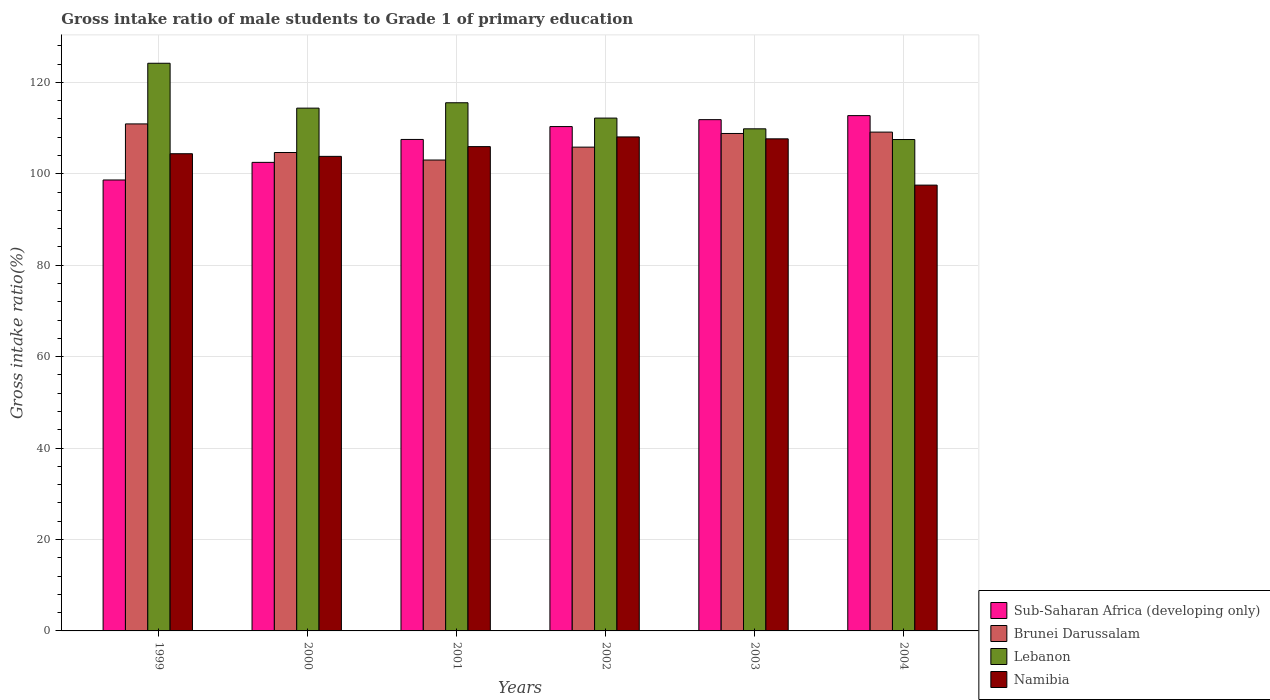How many different coloured bars are there?
Keep it short and to the point. 4. Are the number of bars per tick equal to the number of legend labels?
Provide a short and direct response. Yes. How many bars are there on the 6th tick from the right?
Keep it short and to the point. 4. What is the gross intake ratio in Lebanon in 2004?
Keep it short and to the point. 107.49. Across all years, what is the maximum gross intake ratio in Lebanon?
Give a very brief answer. 124.17. Across all years, what is the minimum gross intake ratio in Brunei Darussalam?
Ensure brevity in your answer.  103. In which year was the gross intake ratio in Sub-Saharan Africa (developing only) minimum?
Provide a succinct answer. 1999. What is the total gross intake ratio in Brunei Darussalam in the graph?
Provide a short and direct response. 642.31. What is the difference between the gross intake ratio in Brunei Darussalam in 2000 and that in 2001?
Offer a terse response. 1.64. What is the difference between the gross intake ratio in Brunei Darussalam in 2003 and the gross intake ratio in Lebanon in 2001?
Make the answer very short. -6.72. What is the average gross intake ratio in Sub-Saharan Africa (developing only) per year?
Ensure brevity in your answer.  107.25. In the year 1999, what is the difference between the gross intake ratio in Sub-Saharan Africa (developing only) and gross intake ratio in Lebanon?
Offer a very short reply. -25.53. In how many years, is the gross intake ratio in Sub-Saharan Africa (developing only) greater than 20 %?
Keep it short and to the point. 6. What is the ratio of the gross intake ratio in Namibia in 2000 to that in 2002?
Give a very brief answer. 0.96. Is the difference between the gross intake ratio in Sub-Saharan Africa (developing only) in 2000 and 2002 greater than the difference between the gross intake ratio in Lebanon in 2000 and 2002?
Ensure brevity in your answer.  No. What is the difference between the highest and the second highest gross intake ratio in Brunei Darussalam?
Offer a terse response. 1.79. What is the difference between the highest and the lowest gross intake ratio in Sub-Saharan Africa (developing only)?
Provide a succinct answer. 14.08. In how many years, is the gross intake ratio in Namibia greater than the average gross intake ratio in Namibia taken over all years?
Provide a succinct answer. 3. Is it the case that in every year, the sum of the gross intake ratio in Sub-Saharan Africa (developing only) and gross intake ratio in Brunei Darussalam is greater than the sum of gross intake ratio in Namibia and gross intake ratio in Lebanon?
Provide a short and direct response. No. What does the 4th bar from the left in 1999 represents?
Give a very brief answer. Namibia. What does the 3rd bar from the right in 2000 represents?
Your answer should be compact. Brunei Darussalam. How many bars are there?
Ensure brevity in your answer.  24. How many years are there in the graph?
Your answer should be very brief. 6. Are the values on the major ticks of Y-axis written in scientific E-notation?
Provide a succinct answer. No. Does the graph contain any zero values?
Give a very brief answer. No. Does the graph contain grids?
Your answer should be compact. Yes. Where does the legend appear in the graph?
Provide a short and direct response. Bottom right. How many legend labels are there?
Make the answer very short. 4. How are the legend labels stacked?
Provide a succinct answer. Vertical. What is the title of the graph?
Your answer should be compact. Gross intake ratio of male students to Grade 1 of primary education. What is the label or title of the X-axis?
Your response must be concise. Years. What is the label or title of the Y-axis?
Offer a very short reply. Gross intake ratio(%). What is the Gross intake ratio(%) in Sub-Saharan Africa (developing only) in 1999?
Provide a short and direct response. 98.64. What is the Gross intake ratio(%) in Brunei Darussalam in 1999?
Provide a short and direct response. 110.91. What is the Gross intake ratio(%) in Lebanon in 1999?
Make the answer very short. 124.17. What is the Gross intake ratio(%) in Namibia in 1999?
Make the answer very short. 104.38. What is the Gross intake ratio(%) in Sub-Saharan Africa (developing only) in 2000?
Keep it short and to the point. 102.49. What is the Gross intake ratio(%) of Brunei Darussalam in 2000?
Provide a succinct answer. 104.65. What is the Gross intake ratio(%) of Lebanon in 2000?
Keep it short and to the point. 114.35. What is the Gross intake ratio(%) of Namibia in 2000?
Provide a short and direct response. 103.81. What is the Gross intake ratio(%) in Sub-Saharan Africa (developing only) in 2001?
Keep it short and to the point. 107.51. What is the Gross intake ratio(%) in Brunei Darussalam in 2001?
Offer a very short reply. 103. What is the Gross intake ratio(%) in Lebanon in 2001?
Your answer should be very brief. 115.53. What is the Gross intake ratio(%) of Namibia in 2001?
Offer a terse response. 105.94. What is the Gross intake ratio(%) of Sub-Saharan Africa (developing only) in 2002?
Give a very brief answer. 110.32. What is the Gross intake ratio(%) in Brunei Darussalam in 2002?
Provide a short and direct response. 105.83. What is the Gross intake ratio(%) in Lebanon in 2002?
Offer a terse response. 112.18. What is the Gross intake ratio(%) in Namibia in 2002?
Your answer should be very brief. 108.06. What is the Gross intake ratio(%) in Sub-Saharan Africa (developing only) in 2003?
Offer a terse response. 111.84. What is the Gross intake ratio(%) of Brunei Darussalam in 2003?
Your answer should be very brief. 108.81. What is the Gross intake ratio(%) in Lebanon in 2003?
Your response must be concise. 109.83. What is the Gross intake ratio(%) of Namibia in 2003?
Offer a terse response. 107.64. What is the Gross intake ratio(%) of Sub-Saharan Africa (developing only) in 2004?
Ensure brevity in your answer.  112.72. What is the Gross intake ratio(%) of Brunei Darussalam in 2004?
Provide a succinct answer. 109.11. What is the Gross intake ratio(%) in Lebanon in 2004?
Provide a short and direct response. 107.49. What is the Gross intake ratio(%) of Namibia in 2004?
Your response must be concise. 97.52. Across all years, what is the maximum Gross intake ratio(%) in Sub-Saharan Africa (developing only)?
Give a very brief answer. 112.72. Across all years, what is the maximum Gross intake ratio(%) in Brunei Darussalam?
Keep it short and to the point. 110.91. Across all years, what is the maximum Gross intake ratio(%) in Lebanon?
Your response must be concise. 124.17. Across all years, what is the maximum Gross intake ratio(%) in Namibia?
Ensure brevity in your answer.  108.06. Across all years, what is the minimum Gross intake ratio(%) in Sub-Saharan Africa (developing only)?
Your response must be concise. 98.64. Across all years, what is the minimum Gross intake ratio(%) in Brunei Darussalam?
Offer a terse response. 103. Across all years, what is the minimum Gross intake ratio(%) of Lebanon?
Your answer should be compact. 107.49. Across all years, what is the minimum Gross intake ratio(%) in Namibia?
Offer a terse response. 97.52. What is the total Gross intake ratio(%) in Sub-Saharan Africa (developing only) in the graph?
Give a very brief answer. 643.52. What is the total Gross intake ratio(%) of Brunei Darussalam in the graph?
Provide a succinct answer. 642.31. What is the total Gross intake ratio(%) of Lebanon in the graph?
Offer a terse response. 683.55. What is the total Gross intake ratio(%) of Namibia in the graph?
Offer a terse response. 627.34. What is the difference between the Gross intake ratio(%) of Sub-Saharan Africa (developing only) in 1999 and that in 2000?
Your answer should be compact. -3.85. What is the difference between the Gross intake ratio(%) of Brunei Darussalam in 1999 and that in 2000?
Keep it short and to the point. 6.26. What is the difference between the Gross intake ratio(%) in Lebanon in 1999 and that in 2000?
Make the answer very short. 9.82. What is the difference between the Gross intake ratio(%) of Namibia in 1999 and that in 2000?
Your response must be concise. 0.57. What is the difference between the Gross intake ratio(%) in Sub-Saharan Africa (developing only) in 1999 and that in 2001?
Ensure brevity in your answer.  -8.87. What is the difference between the Gross intake ratio(%) of Brunei Darussalam in 1999 and that in 2001?
Ensure brevity in your answer.  7.9. What is the difference between the Gross intake ratio(%) in Lebanon in 1999 and that in 2001?
Your response must be concise. 8.64. What is the difference between the Gross intake ratio(%) in Namibia in 1999 and that in 2001?
Provide a short and direct response. -1.56. What is the difference between the Gross intake ratio(%) of Sub-Saharan Africa (developing only) in 1999 and that in 2002?
Your answer should be compact. -11.68. What is the difference between the Gross intake ratio(%) of Brunei Darussalam in 1999 and that in 2002?
Provide a short and direct response. 5.08. What is the difference between the Gross intake ratio(%) of Lebanon in 1999 and that in 2002?
Ensure brevity in your answer.  11.99. What is the difference between the Gross intake ratio(%) of Namibia in 1999 and that in 2002?
Your response must be concise. -3.68. What is the difference between the Gross intake ratio(%) of Sub-Saharan Africa (developing only) in 1999 and that in 2003?
Provide a succinct answer. -13.2. What is the difference between the Gross intake ratio(%) in Brunei Darussalam in 1999 and that in 2003?
Offer a very short reply. 2.09. What is the difference between the Gross intake ratio(%) in Lebanon in 1999 and that in 2003?
Ensure brevity in your answer.  14.34. What is the difference between the Gross intake ratio(%) in Namibia in 1999 and that in 2003?
Give a very brief answer. -3.26. What is the difference between the Gross intake ratio(%) in Sub-Saharan Africa (developing only) in 1999 and that in 2004?
Keep it short and to the point. -14.08. What is the difference between the Gross intake ratio(%) in Brunei Darussalam in 1999 and that in 2004?
Your response must be concise. 1.79. What is the difference between the Gross intake ratio(%) in Lebanon in 1999 and that in 2004?
Keep it short and to the point. 16.68. What is the difference between the Gross intake ratio(%) of Namibia in 1999 and that in 2004?
Offer a very short reply. 6.86. What is the difference between the Gross intake ratio(%) of Sub-Saharan Africa (developing only) in 2000 and that in 2001?
Offer a terse response. -5.01. What is the difference between the Gross intake ratio(%) in Brunei Darussalam in 2000 and that in 2001?
Provide a succinct answer. 1.64. What is the difference between the Gross intake ratio(%) of Lebanon in 2000 and that in 2001?
Make the answer very short. -1.18. What is the difference between the Gross intake ratio(%) in Namibia in 2000 and that in 2001?
Provide a succinct answer. -2.13. What is the difference between the Gross intake ratio(%) of Sub-Saharan Africa (developing only) in 2000 and that in 2002?
Make the answer very short. -7.83. What is the difference between the Gross intake ratio(%) of Brunei Darussalam in 2000 and that in 2002?
Your answer should be compact. -1.18. What is the difference between the Gross intake ratio(%) of Lebanon in 2000 and that in 2002?
Your response must be concise. 2.17. What is the difference between the Gross intake ratio(%) of Namibia in 2000 and that in 2002?
Ensure brevity in your answer.  -4.25. What is the difference between the Gross intake ratio(%) in Sub-Saharan Africa (developing only) in 2000 and that in 2003?
Make the answer very short. -9.34. What is the difference between the Gross intake ratio(%) of Brunei Darussalam in 2000 and that in 2003?
Make the answer very short. -4.17. What is the difference between the Gross intake ratio(%) in Lebanon in 2000 and that in 2003?
Make the answer very short. 4.53. What is the difference between the Gross intake ratio(%) in Namibia in 2000 and that in 2003?
Offer a terse response. -3.83. What is the difference between the Gross intake ratio(%) of Sub-Saharan Africa (developing only) in 2000 and that in 2004?
Make the answer very short. -10.23. What is the difference between the Gross intake ratio(%) in Brunei Darussalam in 2000 and that in 2004?
Offer a terse response. -4.47. What is the difference between the Gross intake ratio(%) in Lebanon in 2000 and that in 2004?
Make the answer very short. 6.87. What is the difference between the Gross intake ratio(%) in Namibia in 2000 and that in 2004?
Provide a succinct answer. 6.29. What is the difference between the Gross intake ratio(%) of Sub-Saharan Africa (developing only) in 2001 and that in 2002?
Offer a very short reply. -2.82. What is the difference between the Gross intake ratio(%) of Brunei Darussalam in 2001 and that in 2002?
Offer a terse response. -2.82. What is the difference between the Gross intake ratio(%) of Lebanon in 2001 and that in 2002?
Provide a succinct answer. 3.35. What is the difference between the Gross intake ratio(%) in Namibia in 2001 and that in 2002?
Provide a succinct answer. -2.12. What is the difference between the Gross intake ratio(%) of Sub-Saharan Africa (developing only) in 2001 and that in 2003?
Give a very brief answer. -4.33. What is the difference between the Gross intake ratio(%) of Brunei Darussalam in 2001 and that in 2003?
Keep it short and to the point. -5.81. What is the difference between the Gross intake ratio(%) of Lebanon in 2001 and that in 2003?
Offer a very short reply. 5.7. What is the difference between the Gross intake ratio(%) in Namibia in 2001 and that in 2003?
Your answer should be compact. -1.7. What is the difference between the Gross intake ratio(%) of Sub-Saharan Africa (developing only) in 2001 and that in 2004?
Offer a very short reply. -5.21. What is the difference between the Gross intake ratio(%) of Brunei Darussalam in 2001 and that in 2004?
Your answer should be very brief. -6.11. What is the difference between the Gross intake ratio(%) in Lebanon in 2001 and that in 2004?
Give a very brief answer. 8.04. What is the difference between the Gross intake ratio(%) in Namibia in 2001 and that in 2004?
Ensure brevity in your answer.  8.42. What is the difference between the Gross intake ratio(%) in Sub-Saharan Africa (developing only) in 2002 and that in 2003?
Offer a very short reply. -1.51. What is the difference between the Gross intake ratio(%) of Brunei Darussalam in 2002 and that in 2003?
Make the answer very short. -2.99. What is the difference between the Gross intake ratio(%) of Lebanon in 2002 and that in 2003?
Give a very brief answer. 2.35. What is the difference between the Gross intake ratio(%) of Namibia in 2002 and that in 2003?
Offer a terse response. 0.42. What is the difference between the Gross intake ratio(%) of Sub-Saharan Africa (developing only) in 2002 and that in 2004?
Keep it short and to the point. -2.4. What is the difference between the Gross intake ratio(%) of Brunei Darussalam in 2002 and that in 2004?
Give a very brief answer. -3.29. What is the difference between the Gross intake ratio(%) in Lebanon in 2002 and that in 2004?
Your answer should be compact. 4.69. What is the difference between the Gross intake ratio(%) in Namibia in 2002 and that in 2004?
Give a very brief answer. 10.54. What is the difference between the Gross intake ratio(%) of Sub-Saharan Africa (developing only) in 2003 and that in 2004?
Your response must be concise. -0.88. What is the difference between the Gross intake ratio(%) of Brunei Darussalam in 2003 and that in 2004?
Offer a terse response. -0.3. What is the difference between the Gross intake ratio(%) in Lebanon in 2003 and that in 2004?
Ensure brevity in your answer.  2.34. What is the difference between the Gross intake ratio(%) of Namibia in 2003 and that in 2004?
Keep it short and to the point. 10.12. What is the difference between the Gross intake ratio(%) in Sub-Saharan Africa (developing only) in 1999 and the Gross intake ratio(%) in Brunei Darussalam in 2000?
Ensure brevity in your answer.  -6.01. What is the difference between the Gross intake ratio(%) in Sub-Saharan Africa (developing only) in 1999 and the Gross intake ratio(%) in Lebanon in 2000?
Make the answer very short. -15.71. What is the difference between the Gross intake ratio(%) of Sub-Saharan Africa (developing only) in 1999 and the Gross intake ratio(%) of Namibia in 2000?
Offer a very short reply. -5.17. What is the difference between the Gross intake ratio(%) of Brunei Darussalam in 1999 and the Gross intake ratio(%) of Lebanon in 2000?
Provide a short and direct response. -3.45. What is the difference between the Gross intake ratio(%) of Brunei Darussalam in 1999 and the Gross intake ratio(%) of Namibia in 2000?
Offer a very short reply. 7.1. What is the difference between the Gross intake ratio(%) in Lebanon in 1999 and the Gross intake ratio(%) in Namibia in 2000?
Provide a succinct answer. 20.37. What is the difference between the Gross intake ratio(%) of Sub-Saharan Africa (developing only) in 1999 and the Gross intake ratio(%) of Brunei Darussalam in 2001?
Your answer should be very brief. -4.36. What is the difference between the Gross intake ratio(%) of Sub-Saharan Africa (developing only) in 1999 and the Gross intake ratio(%) of Lebanon in 2001?
Your answer should be very brief. -16.89. What is the difference between the Gross intake ratio(%) of Sub-Saharan Africa (developing only) in 1999 and the Gross intake ratio(%) of Namibia in 2001?
Keep it short and to the point. -7.3. What is the difference between the Gross intake ratio(%) of Brunei Darussalam in 1999 and the Gross intake ratio(%) of Lebanon in 2001?
Keep it short and to the point. -4.62. What is the difference between the Gross intake ratio(%) of Brunei Darussalam in 1999 and the Gross intake ratio(%) of Namibia in 2001?
Provide a succinct answer. 4.97. What is the difference between the Gross intake ratio(%) in Lebanon in 1999 and the Gross intake ratio(%) in Namibia in 2001?
Give a very brief answer. 18.23. What is the difference between the Gross intake ratio(%) of Sub-Saharan Africa (developing only) in 1999 and the Gross intake ratio(%) of Brunei Darussalam in 2002?
Your answer should be compact. -7.19. What is the difference between the Gross intake ratio(%) in Sub-Saharan Africa (developing only) in 1999 and the Gross intake ratio(%) in Lebanon in 2002?
Provide a short and direct response. -13.54. What is the difference between the Gross intake ratio(%) in Sub-Saharan Africa (developing only) in 1999 and the Gross intake ratio(%) in Namibia in 2002?
Ensure brevity in your answer.  -9.42. What is the difference between the Gross intake ratio(%) of Brunei Darussalam in 1999 and the Gross intake ratio(%) of Lebanon in 2002?
Provide a succinct answer. -1.27. What is the difference between the Gross intake ratio(%) in Brunei Darussalam in 1999 and the Gross intake ratio(%) in Namibia in 2002?
Keep it short and to the point. 2.85. What is the difference between the Gross intake ratio(%) in Lebanon in 1999 and the Gross intake ratio(%) in Namibia in 2002?
Offer a terse response. 16.11. What is the difference between the Gross intake ratio(%) of Sub-Saharan Africa (developing only) in 1999 and the Gross intake ratio(%) of Brunei Darussalam in 2003?
Ensure brevity in your answer.  -10.17. What is the difference between the Gross intake ratio(%) of Sub-Saharan Africa (developing only) in 1999 and the Gross intake ratio(%) of Lebanon in 2003?
Your answer should be compact. -11.19. What is the difference between the Gross intake ratio(%) of Sub-Saharan Africa (developing only) in 1999 and the Gross intake ratio(%) of Namibia in 2003?
Ensure brevity in your answer.  -9. What is the difference between the Gross intake ratio(%) in Brunei Darussalam in 1999 and the Gross intake ratio(%) in Lebanon in 2003?
Make the answer very short. 1.08. What is the difference between the Gross intake ratio(%) of Brunei Darussalam in 1999 and the Gross intake ratio(%) of Namibia in 2003?
Offer a very short reply. 3.27. What is the difference between the Gross intake ratio(%) of Lebanon in 1999 and the Gross intake ratio(%) of Namibia in 2003?
Your answer should be very brief. 16.53. What is the difference between the Gross intake ratio(%) in Sub-Saharan Africa (developing only) in 1999 and the Gross intake ratio(%) in Brunei Darussalam in 2004?
Make the answer very short. -10.47. What is the difference between the Gross intake ratio(%) in Sub-Saharan Africa (developing only) in 1999 and the Gross intake ratio(%) in Lebanon in 2004?
Give a very brief answer. -8.85. What is the difference between the Gross intake ratio(%) of Sub-Saharan Africa (developing only) in 1999 and the Gross intake ratio(%) of Namibia in 2004?
Provide a succinct answer. 1.12. What is the difference between the Gross intake ratio(%) in Brunei Darussalam in 1999 and the Gross intake ratio(%) in Lebanon in 2004?
Offer a terse response. 3.42. What is the difference between the Gross intake ratio(%) of Brunei Darussalam in 1999 and the Gross intake ratio(%) of Namibia in 2004?
Offer a terse response. 13.39. What is the difference between the Gross intake ratio(%) of Lebanon in 1999 and the Gross intake ratio(%) of Namibia in 2004?
Your answer should be compact. 26.65. What is the difference between the Gross intake ratio(%) of Sub-Saharan Africa (developing only) in 2000 and the Gross intake ratio(%) of Brunei Darussalam in 2001?
Your response must be concise. -0.51. What is the difference between the Gross intake ratio(%) of Sub-Saharan Africa (developing only) in 2000 and the Gross intake ratio(%) of Lebanon in 2001?
Give a very brief answer. -13.04. What is the difference between the Gross intake ratio(%) of Sub-Saharan Africa (developing only) in 2000 and the Gross intake ratio(%) of Namibia in 2001?
Your response must be concise. -3.44. What is the difference between the Gross intake ratio(%) of Brunei Darussalam in 2000 and the Gross intake ratio(%) of Lebanon in 2001?
Provide a short and direct response. -10.88. What is the difference between the Gross intake ratio(%) of Brunei Darussalam in 2000 and the Gross intake ratio(%) of Namibia in 2001?
Offer a terse response. -1.29. What is the difference between the Gross intake ratio(%) in Lebanon in 2000 and the Gross intake ratio(%) in Namibia in 2001?
Your answer should be compact. 8.42. What is the difference between the Gross intake ratio(%) of Sub-Saharan Africa (developing only) in 2000 and the Gross intake ratio(%) of Brunei Darussalam in 2002?
Provide a succinct answer. -3.33. What is the difference between the Gross intake ratio(%) of Sub-Saharan Africa (developing only) in 2000 and the Gross intake ratio(%) of Lebanon in 2002?
Provide a succinct answer. -9.69. What is the difference between the Gross intake ratio(%) in Sub-Saharan Africa (developing only) in 2000 and the Gross intake ratio(%) in Namibia in 2002?
Ensure brevity in your answer.  -5.56. What is the difference between the Gross intake ratio(%) in Brunei Darussalam in 2000 and the Gross intake ratio(%) in Lebanon in 2002?
Your answer should be very brief. -7.53. What is the difference between the Gross intake ratio(%) in Brunei Darussalam in 2000 and the Gross intake ratio(%) in Namibia in 2002?
Offer a terse response. -3.41. What is the difference between the Gross intake ratio(%) of Lebanon in 2000 and the Gross intake ratio(%) of Namibia in 2002?
Your answer should be very brief. 6.3. What is the difference between the Gross intake ratio(%) of Sub-Saharan Africa (developing only) in 2000 and the Gross intake ratio(%) of Brunei Darussalam in 2003?
Your response must be concise. -6.32. What is the difference between the Gross intake ratio(%) in Sub-Saharan Africa (developing only) in 2000 and the Gross intake ratio(%) in Lebanon in 2003?
Provide a short and direct response. -7.34. What is the difference between the Gross intake ratio(%) of Sub-Saharan Africa (developing only) in 2000 and the Gross intake ratio(%) of Namibia in 2003?
Your response must be concise. -5.14. What is the difference between the Gross intake ratio(%) in Brunei Darussalam in 2000 and the Gross intake ratio(%) in Lebanon in 2003?
Make the answer very short. -5.18. What is the difference between the Gross intake ratio(%) in Brunei Darussalam in 2000 and the Gross intake ratio(%) in Namibia in 2003?
Your answer should be compact. -2.99. What is the difference between the Gross intake ratio(%) in Lebanon in 2000 and the Gross intake ratio(%) in Namibia in 2003?
Provide a short and direct response. 6.72. What is the difference between the Gross intake ratio(%) of Sub-Saharan Africa (developing only) in 2000 and the Gross intake ratio(%) of Brunei Darussalam in 2004?
Provide a succinct answer. -6.62. What is the difference between the Gross intake ratio(%) of Sub-Saharan Africa (developing only) in 2000 and the Gross intake ratio(%) of Lebanon in 2004?
Provide a short and direct response. -5. What is the difference between the Gross intake ratio(%) of Sub-Saharan Africa (developing only) in 2000 and the Gross intake ratio(%) of Namibia in 2004?
Keep it short and to the point. 4.98. What is the difference between the Gross intake ratio(%) of Brunei Darussalam in 2000 and the Gross intake ratio(%) of Lebanon in 2004?
Your response must be concise. -2.84. What is the difference between the Gross intake ratio(%) in Brunei Darussalam in 2000 and the Gross intake ratio(%) in Namibia in 2004?
Provide a short and direct response. 7.13. What is the difference between the Gross intake ratio(%) in Lebanon in 2000 and the Gross intake ratio(%) in Namibia in 2004?
Provide a succinct answer. 16.84. What is the difference between the Gross intake ratio(%) in Sub-Saharan Africa (developing only) in 2001 and the Gross intake ratio(%) in Brunei Darussalam in 2002?
Make the answer very short. 1.68. What is the difference between the Gross intake ratio(%) of Sub-Saharan Africa (developing only) in 2001 and the Gross intake ratio(%) of Lebanon in 2002?
Offer a terse response. -4.67. What is the difference between the Gross intake ratio(%) in Sub-Saharan Africa (developing only) in 2001 and the Gross intake ratio(%) in Namibia in 2002?
Give a very brief answer. -0.55. What is the difference between the Gross intake ratio(%) in Brunei Darussalam in 2001 and the Gross intake ratio(%) in Lebanon in 2002?
Your response must be concise. -9.18. What is the difference between the Gross intake ratio(%) in Brunei Darussalam in 2001 and the Gross intake ratio(%) in Namibia in 2002?
Provide a short and direct response. -5.05. What is the difference between the Gross intake ratio(%) in Lebanon in 2001 and the Gross intake ratio(%) in Namibia in 2002?
Give a very brief answer. 7.47. What is the difference between the Gross intake ratio(%) in Sub-Saharan Africa (developing only) in 2001 and the Gross intake ratio(%) in Brunei Darussalam in 2003?
Provide a succinct answer. -1.31. What is the difference between the Gross intake ratio(%) in Sub-Saharan Africa (developing only) in 2001 and the Gross intake ratio(%) in Lebanon in 2003?
Provide a short and direct response. -2.32. What is the difference between the Gross intake ratio(%) of Sub-Saharan Africa (developing only) in 2001 and the Gross intake ratio(%) of Namibia in 2003?
Provide a succinct answer. -0.13. What is the difference between the Gross intake ratio(%) in Brunei Darussalam in 2001 and the Gross intake ratio(%) in Lebanon in 2003?
Keep it short and to the point. -6.83. What is the difference between the Gross intake ratio(%) in Brunei Darussalam in 2001 and the Gross intake ratio(%) in Namibia in 2003?
Your answer should be compact. -4.63. What is the difference between the Gross intake ratio(%) of Lebanon in 2001 and the Gross intake ratio(%) of Namibia in 2003?
Your answer should be very brief. 7.89. What is the difference between the Gross intake ratio(%) of Sub-Saharan Africa (developing only) in 2001 and the Gross intake ratio(%) of Brunei Darussalam in 2004?
Your answer should be compact. -1.61. What is the difference between the Gross intake ratio(%) of Sub-Saharan Africa (developing only) in 2001 and the Gross intake ratio(%) of Lebanon in 2004?
Provide a short and direct response. 0.02. What is the difference between the Gross intake ratio(%) in Sub-Saharan Africa (developing only) in 2001 and the Gross intake ratio(%) in Namibia in 2004?
Your response must be concise. 9.99. What is the difference between the Gross intake ratio(%) of Brunei Darussalam in 2001 and the Gross intake ratio(%) of Lebanon in 2004?
Make the answer very short. -4.49. What is the difference between the Gross intake ratio(%) in Brunei Darussalam in 2001 and the Gross intake ratio(%) in Namibia in 2004?
Give a very brief answer. 5.49. What is the difference between the Gross intake ratio(%) in Lebanon in 2001 and the Gross intake ratio(%) in Namibia in 2004?
Offer a very short reply. 18.01. What is the difference between the Gross intake ratio(%) of Sub-Saharan Africa (developing only) in 2002 and the Gross intake ratio(%) of Brunei Darussalam in 2003?
Keep it short and to the point. 1.51. What is the difference between the Gross intake ratio(%) in Sub-Saharan Africa (developing only) in 2002 and the Gross intake ratio(%) in Lebanon in 2003?
Your answer should be compact. 0.49. What is the difference between the Gross intake ratio(%) of Sub-Saharan Africa (developing only) in 2002 and the Gross intake ratio(%) of Namibia in 2003?
Your answer should be compact. 2.68. What is the difference between the Gross intake ratio(%) in Brunei Darussalam in 2002 and the Gross intake ratio(%) in Lebanon in 2003?
Make the answer very short. -4. What is the difference between the Gross intake ratio(%) of Brunei Darussalam in 2002 and the Gross intake ratio(%) of Namibia in 2003?
Your answer should be compact. -1.81. What is the difference between the Gross intake ratio(%) in Lebanon in 2002 and the Gross intake ratio(%) in Namibia in 2003?
Keep it short and to the point. 4.54. What is the difference between the Gross intake ratio(%) in Sub-Saharan Africa (developing only) in 2002 and the Gross intake ratio(%) in Brunei Darussalam in 2004?
Your answer should be compact. 1.21. What is the difference between the Gross intake ratio(%) in Sub-Saharan Africa (developing only) in 2002 and the Gross intake ratio(%) in Lebanon in 2004?
Ensure brevity in your answer.  2.83. What is the difference between the Gross intake ratio(%) of Sub-Saharan Africa (developing only) in 2002 and the Gross intake ratio(%) of Namibia in 2004?
Give a very brief answer. 12.81. What is the difference between the Gross intake ratio(%) in Brunei Darussalam in 2002 and the Gross intake ratio(%) in Lebanon in 2004?
Provide a succinct answer. -1.66. What is the difference between the Gross intake ratio(%) in Brunei Darussalam in 2002 and the Gross intake ratio(%) in Namibia in 2004?
Offer a very short reply. 8.31. What is the difference between the Gross intake ratio(%) in Lebanon in 2002 and the Gross intake ratio(%) in Namibia in 2004?
Give a very brief answer. 14.66. What is the difference between the Gross intake ratio(%) in Sub-Saharan Africa (developing only) in 2003 and the Gross intake ratio(%) in Brunei Darussalam in 2004?
Your response must be concise. 2.72. What is the difference between the Gross intake ratio(%) of Sub-Saharan Africa (developing only) in 2003 and the Gross intake ratio(%) of Lebanon in 2004?
Give a very brief answer. 4.35. What is the difference between the Gross intake ratio(%) of Sub-Saharan Africa (developing only) in 2003 and the Gross intake ratio(%) of Namibia in 2004?
Provide a succinct answer. 14.32. What is the difference between the Gross intake ratio(%) in Brunei Darussalam in 2003 and the Gross intake ratio(%) in Lebanon in 2004?
Give a very brief answer. 1.32. What is the difference between the Gross intake ratio(%) in Brunei Darussalam in 2003 and the Gross intake ratio(%) in Namibia in 2004?
Your answer should be very brief. 11.3. What is the difference between the Gross intake ratio(%) of Lebanon in 2003 and the Gross intake ratio(%) of Namibia in 2004?
Give a very brief answer. 12.31. What is the average Gross intake ratio(%) in Sub-Saharan Africa (developing only) per year?
Offer a very short reply. 107.25. What is the average Gross intake ratio(%) of Brunei Darussalam per year?
Provide a short and direct response. 107.05. What is the average Gross intake ratio(%) in Lebanon per year?
Give a very brief answer. 113.93. What is the average Gross intake ratio(%) in Namibia per year?
Your answer should be compact. 104.56. In the year 1999, what is the difference between the Gross intake ratio(%) of Sub-Saharan Africa (developing only) and Gross intake ratio(%) of Brunei Darussalam?
Give a very brief answer. -12.27. In the year 1999, what is the difference between the Gross intake ratio(%) of Sub-Saharan Africa (developing only) and Gross intake ratio(%) of Lebanon?
Provide a succinct answer. -25.53. In the year 1999, what is the difference between the Gross intake ratio(%) in Sub-Saharan Africa (developing only) and Gross intake ratio(%) in Namibia?
Offer a very short reply. -5.74. In the year 1999, what is the difference between the Gross intake ratio(%) in Brunei Darussalam and Gross intake ratio(%) in Lebanon?
Your response must be concise. -13.27. In the year 1999, what is the difference between the Gross intake ratio(%) of Brunei Darussalam and Gross intake ratio(%) of Namibia?
Ensure brevity in your answer.  6.52. In the year 1999, what is the difference between the Gross intake ratio(%) of Lebanon and Gross intake ratio(%) of Namibia?
Make the answer very short. 19.79. In the year 2000, what is the difference between the Gross intake ratio(%) in Sub-Saharan Africa (developing only) and Gross intake ratio(%) in Brunei Darussalam?
Your answer should be very brief. -2.15. In the year 2000, what is the difference between the Gross intake ratio(%) in Sub-Saharan Africa (developing only) and Gross intake ratio(%) in Lebanon?
Provide a succinct answer. -11.86. In the year 2000, what is the difference between the Gross intake ratio(%) in Sub-Saharan Africa (developing only) and Gross intake ratio(%) in Namibia?
Make the answer very short. -1.31. In the year 2000, what is the difference between the Gross intake ratio(%) in Brunei Darussalam and Gross intake ratio(%) in Lebanon?
Provide a short and direct response. -9.71. In the year 2000, what is the difference between the Gross intake ratio(%) of Brunei Darussalam and Gross intake ratio(%) of Namibia?
Your answer should be very brief. 0.84. In the year 2000, what is the difference between the Gross intake ratio(%) of Lebanon and Gross intake ratio(%) of Namibia?
Make the answer very short. 10.55. In the year 2001, what is the difference between the Gross intake ratio(%) of Sub-Saharan Africa (developing only) and Gross intake ratio(%) of Brunei Darussalam?
Provide a short and direct response. 4.5. In the year 2001, what is the difference between the Gross intake ratio(%) in Sub-Saharan Africa (developing only) and Gross intake ratio(%) in Lebanon?
Your response must be concise. -8.02. In the year 2001, what is the difference between the Gross intake ratio(%) in Sub-Saharan Africa (developing only) and Gross intake ratio(%) in Namibia?
Offer a terse response. 1.57. In the year 2001, what is the difference between the Gross intake ratio(%) in Brunei Darussalam and Gross intake ratio(%) in Lebanon?
Provide a succinct answer. -12.53. In the year 2001, what is the difference between the Gross intake ratio(%) in Brunei Darussalam and Gross intake ratio(%) in Namibia?
Your answer should be compact. -2.93. In the year 2001, what is the difference between the Gross intake ratio(%) in Lebanon and Gross intake ratio(%) in Namibia?
Offer a terse response. 9.59. In the year 2002, what is the difference between the Gross intake ratio(%) in Sub-Saharan Africa (developing only) and Gross intake ratio(%) in Brunei Darussalam?
Provide a short and direct response. 4.5. In the year 2002, what is the difference between the Gross intake ratio(%) of Sub-Saharan Africa (developing only) and Gross intake ratio(%) of Lebanon?
Your response must be concise. -1.86. In the year 2002, what is the difference between the Gross intake ratio(%) in Sub-Saharan Africa (developing only) and Gross intake ratio(%) in Namibia?
Your answer should be very brief. 2.26. In the year 2002, what is the difference between the Gross intake ratio(%) of Brunei Darussalam and Gross intake ratio(%) of Lebanon?
Provide a short and direct response. -6.35. In the year 2002, what is the difference between the Gross intake ratio(%) of Brunei Darussalam and Gross intake ratio(%) of Namibia?
Ensure brevity in your answer.  -2.23. In the year 2002, what is the difference between the Gross intake ratio(%) in Lebanon and Gross intake ratio(%) in Namibia?
Your response must be concise. 4.12. In the year 2003, what is the difference between the Gross intake ratio(%) in Sub-Saharan Africa (developing only) and Gross intake ratio(%) in Brunei Darussalam?
Offer a terse response. 3.02. In the year 2003, what is the difference between the Gross intake ratio(%) in Sub-Saharan Africa (developing only) and Gross intake ratio(%) in Lebanon?
Your answer should be compact. 2.01. In the year 2003, what is the difference between the Gross intake ratio(%) in Sub-Saharan Africa (developing only) and Gross intake ratio(%) in Namibia?
Provide a succinct answer. 4.2. In the year 2003, what is the difference between the Gross intake ratio(%) in Brunei Darussalam and Gross intake ratio(%) in Lebanon?
Keep it short and to the point. -1.02. In the year 2003, what is the difference between the Gross intake ratio(%) in Brunei Darussalam and Gross intake ratio(%) in Namibia?
Give a very brief answer. 1.18. In the year 2003, what is the difference between the Gross intake ratio(%) in Lebanon and Gross intake ratio(%) in Namibia?
Make the answer very short. 2.19. In the year 2004, what is the difference between the Gross intake ratio(%) of Sub-Saharan Africa (developing only) and Gross intake ratio(%) of Brunei Darussalam?
Your response must be concise. 3.61. In the year 2004, what is the difference between the Gross intake ratio(%) of Sub-Saharan Africa (developing only) and Gross intake ratio(%) of Lebanon?
Make the answer very short. 5.23. In the year 2004, what is the difference between the Gross intake ratio(%) in Sub-Saharan Africa (developing only) and Gross intake ratio(%) in Namibia?
Provide a succinct answer. 15.2. In the year 2004, what is the difference between the Gross intake ratio(%) of Brunei Darussalam and Gross intake ratio(%) of Lebanon?
Ensure brevity in your answer.  1.62. In the year 2004, what is the difference between the Gross intake ratio(%) of Brunei Darussalam and Gross intake ratio(%) of Namibia?
Give a very brief answer. 11.6. In the year 2004, what is the difference between the Gross intake ratio(%) in Lebanon and Gross intake ratio(%) in Namibia?
Your response must be concise. 9.97. What is the ratio of the Gross intake ratio(%) in Sub-Saharan Africa (developing only) in 1999 to that in 2000?
Keep it short and to the point. 0.96. What is the ratio of the Gross intake ratio(%) in Brunei Darussalam in 1999 to that in 2000?
Give a very brief answer. 1.06. What is the ratio of the Gross intake ratio(%) of Lebanon in 1999 to that in 2000?
Your response must be concise. 1.09. What is the ratio of the Gross intake ratio(%) in Sub-Saharan Africa (developing only) in 1999 to that in 2001?
Give a very brief answer. 0.92. What is the ratio of the Gross intake ratio(%) of Brunei Darussalam in 1999 to that in 2001?
Offer a very short reply. 1.08. What is the ratio of the Gross intake ratio(%) in Lebanon in 1999 to that in 2001?
Your response must be concise. 1.07. What is the ratio of the Gross intake ratio(%) in Sub-Saharan Africa (developing only) in 1999 to that in 2002?
Your response must be concise. 0.89. What is the ratio of the Gross intake ratio(%) of Brunei Darussalam in 1999 to that in 2002?
Offer a very short reply. 1.05. What is the ratio of the Gross intake ratio(%) of Lebanon in 1999 to that in 2002?
Your answer should be very brief. 1.11. What is the ratio of the Gross intake ratio(%) in Namibia in 1999 to that in 2002?
Provide a short and direct response. 0.97. What is the ratio of the Gross intake ratio(%) in Sub-Saharan Africa (developing only) in 1999 to that in 2003?
Keep it short and to the point. 0.88. What is the ratio of the Gross intake ratio(%) of Brunei Darussalam in 1999 to that in 2003?
Offer a very short reply. 1.02. What is the ratio of the Gross intake ratio(%) of Lebanon in 1999 to that in 2003?
Your response must be concise. 1.13. What is the ratio of the Gross intake ratio(%) in Namibia in 1999 to that in 2003?
Offer a very short reply. 0.97. What is the ratio of the Gross intake ratio(%) in Sub-Saharan Africa (developing only) in 1999 to that in 2004?
Your answer should be very brief. 0.88. What is the ratio of the Gross intake ratio(%) in Brunei Darussalam in 1999 to that in 2004?
Provide a succinct answer. 1.02. What is the ratio of the Gross intake ratio(%) of Lebanon in 1999 to that in 2004?
Ensure brevity in your answer.  1.16. What is the ratio of the Gross intake ratio(%) in Namibia in 1999 to that in 2004?
Offer a terse response. 1.07. What is the ratio of the Gross intake ratio(%) in Sub-Saharan Africa (developing only) in 2000 to that in 2001?
Offer a very short reply. 0.95. What is the ratio of the Gross intake ratio(%) in Brunei Darussalam in 2000 to that in 2001?
Your response must be concise. 1.02. What is the ratio of the Gross intake ratio(%) in Lebanon in 2000 to that in 2001?
Keep it short and to the point. 0.99. What is the ratio of the Gross intake ratio(%) in Namibia in 2000 to that in 2001?
Your answer should be compact. 0.98. What is the ratio of the Gross intake ratio(%) in Sub-Saharan Africa (developing only) in 2000 to that in 2002?
Your answer should be compact. 0.93. What is the ratio of the Gross intake ratio(%) of Brunei Darussalam in 2000 to that in 2002?
Keep it short and to the point. 0.99. What is the ratio of the Gross intake ratio(%) in Lebanon in 2000 to that in 2002?
Ensure brevity in your answer.  1.02. What is the ratio of the Gross intake ratio(%) in Namibia in 2000 to that in 2002?
Offer a terse response. 0.96. What is the ratio of the Gross intake ratio(%) of Sub-Saharan Africa (developing only) in 2000 to that in 2003?
Your answer should be compact. 0.92. What is the ratio of the Gross intake ratio(%) in Brunei Darussalam in 2000 to that in 2003?
Your answer should be compact. 0.96. What is the ratio of the Gross intake ratio(%) of Lebanon in 2000 to that in 2003?
Your answer should be compact. 1.04. What is the ratio of the Gross intake ratio(%) of Namibia in 2000 to that in 2003?
Your answer should be very brief. 0.96. What is the ratio of the Gross intake ratio(%) of Sub-Saharan Africa (developing only) in 2000 to that in 2004?
Provide a succinct answer. 0.91. What is the ratio of the Gross intake ratio(%) in Brunei Darussalam in 2000 to that in 2004?
Offer a very short reply. 0.96. What is the ratio of the Gross intake ratio(%) in Lebanon in 2000 to that in 2004?
Give a very brief answer. 1.06. What is the ratio of the Gross intake ratio(%) of Namibia in 2000 to that in 2004?
Your answer should be very brief. 1.06. What is the ratio of the Gross intake ratio(%) in Sub-Saharan Africa (developing only) in 2001 to that in 2002?
Give a very brief answer. 0.97. What is the ratio of the Gross intake ratio(%) of Brunei Darussalam in 2001 to that in 2002?
Give a very brief answer. 0.97. What is the ratio of the Gross intake ratio(%) in Lebanon in 2001 to that in 2002?
Give a very brief answer. 1.03. What is the ratio of the Gross intake ratio(%) of Namibia in 2001 to that in 2002?
Offer a terse response. 0.98. What is the ratio of the Gross intake ratio(%) in Sub-Saharan Africa (developing only) in 2001 to that in 2003?
Give a very brief answer. 0.96. What is the ratio of the Gross intake ratio(%) of Brunei Darussalam in 2001 to that in 2003?
Offer a terse response. 0.95. What is the ratio of the Gross intake ratio(%) in Lebanon in 2001 to that in 2003?
Provide a succinct answer. 1.05. What is the ratio of the Gross intake ratio(%) in Namibia in 2001 to that in 2003?
Provide a succinct answer. 0.98. What is the ratio of the Gross intake ratio(%) in Sub-Saharan Africa (developing only) in 2001 to that in 2004?
Your answer should be very brief. 0.95. What is the ratio of the Gross intake ratio(%) in Brunei Darussalam in 2001 to that in 2004?
Offer a very short reply. 0.94. What is the ratio of the Gross intake ratio(%) in Lebanon in 2001 to that in 2004?
Ensure brevity in your answer.  1.07. What is the ratio of the Gross intake ratio(%) of Namibia in 2001 to that in 2004?
Keep it short and to the point. 1.09. What is the ratio of the Gross intake ratio(%) of Sub-Saharan Africa (developing only) in 2002 to that in 2003?
Offer a terse response. 0.99. What is the ratio of the Gross intake ratio(%) of Brunei Darussalam in 2002 to that in 2003?
Your answer should be very brief. 0.97. What is the ratio of the Gross intake ratio(%) in Lebanon in 2002 to that in 2003?
Your answer should be very brief. 1.02. What is the ratio of the Gross intake ratio(%) in Namibia in 2002 to that in 2003?
Your response must be concise. 1. What is the ratio of the Gross intake ratio(%) of Sub-Saharan Africa (developing only) in 2002 to that in 2004?
Ensure brevity in your answer.  0.98. What is the ratio of the Gross intake ratio(%) in Brunei Darussalam in 2002 to that in 2004?
Offer a very short reply. 0.97. What is the ratio of the Gross intake ratio(%) in Lebanon in 2002 to that in 2004?
Ensure brevity in your answer.  1.04. What is the ratio of the Gross intake ratio(%) in Namibia in 2002 to that in 2004?
Provide a succinct answer. 1.11. What is the ratio of the Gross intake ratio(%) in Lebanon in 2003 to that in 2004?
Your answer should be compact. 1.02. What is the ratio of the Gross intake ratio(%) in Namibia in 2003 to that in 2004?
Make the answer very short. 1.1. What is the difference between the highest and the second highest Gross intake ratio(%) in Sub-Saharan Africa (developing only)?
Your response must be concise. 0.88. What is the difference between the highest and the second highest Gross intake ratio(%) in Brunei Darussalam?
Provide a short and direct response. 1.79. What is the difference between the highest and the second highest Gross intake ratio(%) of Lebanon?
Your answer should be very brief. 8.64. What is the difference between the highest and the second highest Gross intake ratio(%) of Namibia?
Ensure brevity in your answer.  0.42. What is the difference between the highest and the lowest Gross intake ratio(%) in Sub-Saharan Africa (developing only)?
Make the answer very short. 14.08. What is the difference between the highest and the lowest Gross intake ratio(%) of Brunei Darussalam?
Your answer should be compact. 7.9. What is the difference between the highest and the lowest Gross intake ratio(%) in Lebanon?
Provide a succinct answer. 16.68. What is the difference between the highest and the lowest Gross intake ratio(%) in Namibia?
Offer a terse response. 10.54. 